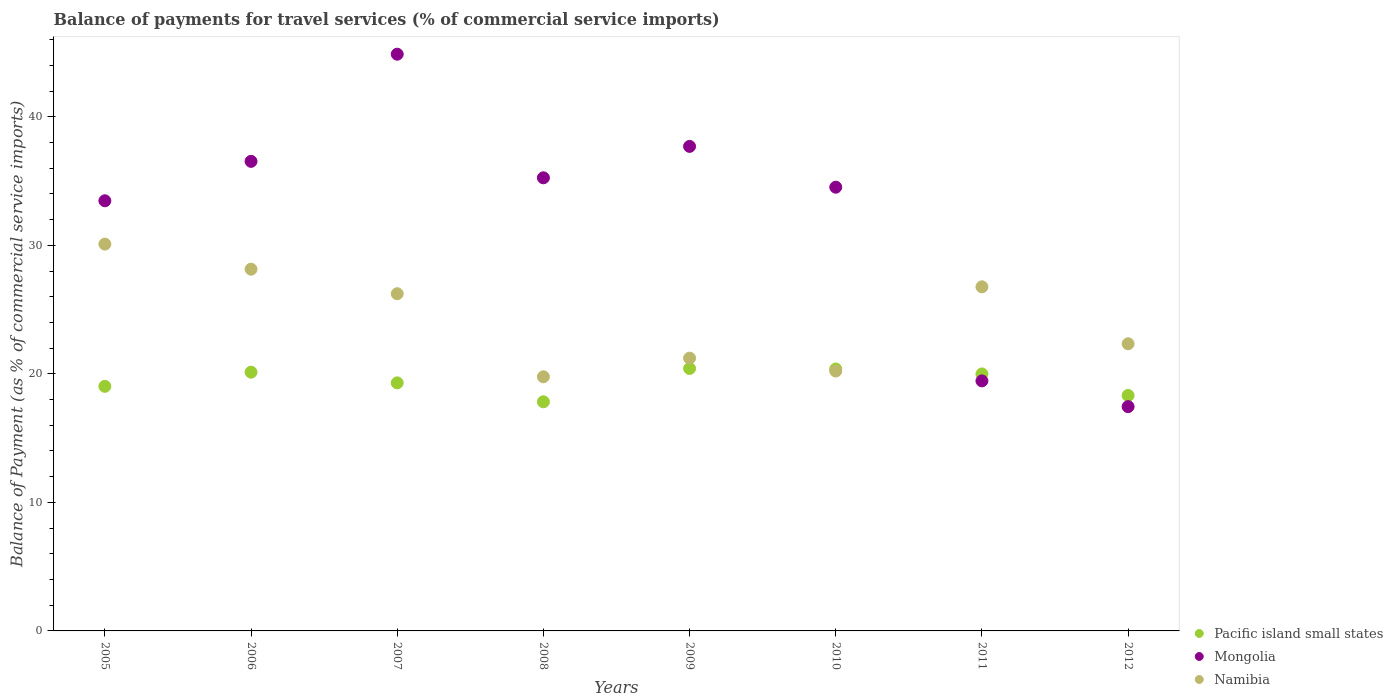How many different coloured dotlines are there?
Your response must be concise. 3. Is the number of dotlines equal to the number of legend labels?
Provide a succinct answer. Yes. What is the balance of payments for travel services in Mongolia in 2008?
Ensure brevity in your answer.  35.26. Across all years, what is the maximum balance of payments for travel services in Mongolia?
Give a very brief answer. 44.87. Across all years, what is the minimum balance of payments for travel services in Pacific island small states?
Your answer should be compact. 17.83. In which year was the balance of payments for travel services in Pacific island small states minimum?
Provide a short and direct response. 2008. What is the total balance of payments for travel services in Mongolia in the graph?
Offer a very short reply. 259.27. What is the difference between the balance of payments for travel services in Pacific island small states in 2008 and that in 2012?
Your response must be concise. -0.49. What is the difference between the balance of payments for travel services in Mongolia in 2006 and the balance of payments for travel services in Namibia in 2007?
Your response must be concise. 10.3. What is the average balance of payments for travel services in Mongolia per year?
Offer a very short reply. 32.41. In the year 2012, what is the difference between the balance of payments for travel services in Namibia and balance of payments for travel services in Pacific island small states?
Offer a terse response. 4.02. What is the ratio of the balance of payments for travel services in Namibia in 2008 to that in 2011?
Offer a very short reply. 0.74. Is the balance of payments for travel services in Namibia in 2005 less than that in 2009?
Make the answer very short. No. Is the difference between the balance of payments for travel services in Namibia in 2007 and 2010 greater than the difference between the balance of payments for travel services in Pacific island small states in 2007 and 2010?
Offer a very short reply. Yes. What is the difference between the highest and the second highest balance of payments for travel services in Namibia?
Ensure brevity in your answer.  1.95. What is the difference between the highest and the lowest balance of payments for travel services in Namibia?
Ensure brevity in your answer.  10.32. In how many years, is the balance of payments for travel services in Pacific island small states greater than the average balance of payments for travel services in Pacific island small states taken over all years?
Ensure brevity in your answer.  4. Is the sum of the balance of payments for travel services in Namibia in 2008 and 2009 greater than the maximum balance of payments for travel services in Pacific island small states across all years?
Make the answer very short. Yes. Is it the case that in every year, the sum of the balance of payments for travel services in Namibia and balance of payments for travel services in Mongolia  is greater than the balance of payments for travel services in Pacific island small states?
Provide a succinct answer. Yes. Does the balance of payments for travel services in Pacific island small states monotonically increase over the years?
Your answer should be compact. No. Is the balance of payments for travel services in Mongolia strictly greater than the balance of payments for travel services in Namibia over the years?
Offer a very short reply. No. How many dotlines are there?
Provide a short and direct response. 3. How many years are there in the graph?
Offer a terse response. 8. Are the values on the major ticks of Y-axis written in scientific E-notation?
Offer a terse response. No. Where does the legend appear in the graph?
Make the answer very short. Bottom right. How many legend labels are there?
Ensure brevity in your answer.  3. What is the title of the graph?
Provide a short and direct response. Balance of payments for travel services (% of commercial service imports). What is the label or title of the Y-axis?
Ensure brevity in your answer.  Balance of Payment (as % of commercial service imports). What is the Balance of Payment (as % of commercial service imports) in Pacific island small states in 2005?
Provide a short and direct response. 19.03. What is the Balance of Payment (as % of commercial service imports) of Mongolia in 2005?
Your answer should be compact. 33.47. What is the Balance of Payment (as % of commercial service imports) in Namibia in 2005?
Your answer should be compact. 30.1. What is the Balance of Payment (as % of commercial service imports) of Pacific island small states in 2006?
Your answer should be very brief. 20.13. What is the Balance of Payment (as % of commercial service imports) of Mongolia in 2006?
Offer a very short reply. 36.54. What is the Balance of Payment (as % of commercial service imports) of Namibia in 2006?
Offer a very short reply. 28.15. What is the Balance of Payment (as % of commercial service imports) in Pacific island small states in 2007?
Keep it short and to the point. 19.3. What is the Balance of Payment (as % of commercial service imports) in Mongolia in 2007?
Keep it short and to the point. 44.87. What is the Balance of Payment (as % of commercial service imports) in Namibia in 2007?
Offer a terse response. 26.24. What is the Balance of Payment (as % of commercial service imports) of Pacific island small states in 2008?
Give a very brief answer. 17.83. What is the Balance of Payment (as % of commercial service imports) in Mongolia in 2008?
Your answer should be very brief. 35.26. What is the Balance of Payment (as % of commercial service imports) of Namibia in 2008?
Your response must be concise. 19.77. What is the Balance of Payment (as % of commercial service imports) of Pacific island small states in 2009?
Keep it short and to the point. 20.42. What is the Balance of Payment (as % of commercial service imports) of Mongolia in 2009?
Provide a short and direct response. 37.7. What is the Balance of Payment (as % of commercial service imports) of Namibia in 2009?
Keep it short and to the point. 21.22. What is the Balance of Payment (as % of commercial service imports) in Pacific island small states in 2010?
Offer a terse response. 20.38. What is the Balance of Payment (as % of commercial service imports) in Mongolia in 2010?
Keep it short and to the point. 34.52. What is the Balance of Payment (as % of commercial service imports) of Namibia in 2010?
Offer a very short reply. 20.22. What is the Balance of Payment (as % of commercial service imports) in Pacific island small states in 2011?
Provide a succinct answer. 20. What is the Balance of Payment (as % of commercial service imports) of Mongolia in 2011?
Provide a succinct answer. 19.45. What is the Balance of Payment (as % of commercial service imports) in Namibia in 2011?
Your response must be concise. 26.77. What is the Balance of Payment (as % of commercial service imports) of Pacific island small states in 2012?
Provide a short and direct response. 18.32. What is the Balance of Payment (as % of commercial service imports) of Mongolia in 2012?
Provide a succinct answer. 17.45. What is the Balance of Payment (as % of commercial service imports) in Namibia in 2012?
Your answer should be compact. 22.34. Across all years, what is the maximum Balance of Payment (as % of commercial service imports) of Pacific island small states?
Offer a terse response. 20.42. Across all years, what is the maximum Balance of Payment (as % of commercial service imports) in Mongolia?
Provide a short and direct response. 44.87. Across all years, what is the maximum Balance of Payment (as % of commercial service imports) in Namibia?
Your response must be concise. 30.1. Across all years, what is the minimum Balance of Payment (as % of commercial service imports) of Pacific island small states?
Your answer should be very brief. 17.83. Across all years, what is the minimum Balance of Payment (as % of commercial service imports) in Mongolia?
Your answer should be compact. 17.45. Across all years, what is the minimum Balance of Payment (as % of commercial service imports) of Namibia?
Keep it short and to the point. 19.77. What is the total Balance of Payment (as % of commercial service imports) in Pacific island small states in the graph?
Make the answer very short. 155.41. What is the total Balance of Payment (as % of commercial service imports) in Mongolia in the graph?
Your answer should be compact. 259.27. What is the total Balance of Payment (as % of commercial service imports) of Namibia in the graph?
Offer a terse response. 194.82. What is the difference between the Balance of Payment (as % of commercial service imports) of Pacific island small states in 2005 and that in 2006?
Your response must be concise. -1.1. What is the difference between the Balance of Payment (as % of commercial service imports) of Mongolia in 2005 and that in 2006?
Ensure brevity in your answer.  -3.07. What is the difference between the Balance of Payment (as % of commercial service imports) in Namibia in 2005 and that in 2006?
Offer a terse response. 1.95. What is the difference between the Balance of Payment (as % of commercial service imports) in Pacific island small states in 2005 and that in 2007?
Your response must be concise. -0.27. What is the difference between the Balance of Payment (as % of commercial service imports) in Mongolia in 2005 and that in 2007?
Offer a very short reply. -11.41. What is the difference between the Balance of Payment (as % of commercial service imports) in Namibia in 2005 and that in 2007?
Your answer should be very brief. 3.86. What is the difference between the Balance of Payment (as % of commercial service imports) of Pacific island small states in 2005 and that in 2008?
Your answer should be very brief. 1.2. What is the difference between the Balance of Payment (as % of commercial service imports) in Mongolia in 2005 and that in 2008?
Give a very brief answer. -1.79. What is the difference between the Balance of Payment (as % of commercial service imports) in Namibia in 2005 and that in 2008?
Your answer should be very brief. 10.32. What is the difference between the Balance of Payment (as % of commercial service imports) of Pacific island small states in 2005 and that in 2009?
Provide a succinct answer. -1.39. What is the difference between the Balance of Payment (as % of commercial service imports) of Mongolia in 2005 and that in 2009?
Offer a terse response. -4.23. What is the difference between the Balance of Payment (as % of commercial service imports) in Namibia in 2005 and that in 2009?
Keep it short and to the point. 8.87. What is the difference between the Balance of Payment (as % of commercial service imports) of Pacific island small states in 2005 and that in 2010?
Your answer should be very brief. -1.35. What is the difference between the Balance of Payment (as % of commercial service imports) in Mongolia in 2005 and that in 2010?
Your response must be concise. -1.06. What is the difference between the Balance of Payment (as % of commercial service imports) in Namibia in 2005 and that in 2010?
Give a very brief answer. 9.88. What is the difference between the Balance of Payment (as % of commercial service imports) of Pacific island small states in 2005 and that in 2011?
Offer a very short reply. -0.97. What is the difference between the Balance of Payment (as % of commercial service imports) in Mongolia in 2005 and that in 2011?
Provide a short and direct response. 14.01. What is the difference between the Balance of Payment (as % of commercial service imports) in Namibia in 2005 and that in 2011?
Provide a short and direct response. 3.32. What is the difference between the Balance of Payment (as % of commercial service imports) of Pacific island small states in 2005 and that in 2012?
Ensure brevity in your answer.  0.71. What is the difference between the Balance of Payment (as % of commercial service imports) in Mongolia in 2005 and that in 2012?
Provide a succinct answer. 16.02. What is the difference between the Balance of Payment (as % of commercial service imports) of Namibia in 2005 and that in 2012?
Offer a terse response. 7.75. What is the difference between the Balance of Payment (as % of commercial service imports) of Pacific island small states in 2006 and that in 2007?
Give a very brief answer. 0.83. What is the difference between the Balance of Payment (as % of commercial service imports) in Mongolia in 2006 and that in 2007?
Offer a terse response. -8.34. What is the difference between the Balance of Payment (as % of commercial service imports) of Namibia in 2006 and that in 2007?
Your response must be concise. 1.91. What is the difference between the Balance of Payment (as % of commercial service imports) of Pacific island small states in 2006 and that in 2008?
Your response must be concise. 2.3. What is the difference between the Balance of Payment (as % of commercial service imports) of Mongolia in 2006 and that in 2008?
Your answer should be very brief. 1.28. What is the difference between the Balance of Payment (as % of commercial service imports) in Namibia in 2006 and that in 2008?
Your response must be concise. 8.37. What is the difference between the Balance of Payment (as % of commercial service imports) in Pacific island small states in 2006 and that in 2009?
Your answer should be compact. -0.29. What is the difference between the Balance of Payment (as % of commercial service imports) of Mongolia in 2006 and that in 2009?
Your response must be concise. -1.16. What is the difference between the Balance of Payment (as % of commercial service imports) of Namibia in 2006 and that in 2009?
Ensure brevity in your answer.  6.92. What is the difference between the Balance of Payment (as % of commercial service imports) of Pacific island small states in 2006 and that in 2010?
Keep it short and to the point. -0.25. What is the difference between the Balance of Payment (as % of commercial service imports) of Mongolia in 2006 and that in 2010?
Provide a succinct answer. 2.01. What is the difference between the Balance of Payment (as % of commercial service imports) of Namibia in 2006 and that in 2010?
Provide a succinct answer. 7.93. What is the difference between the Balance of Payment (as % of commercial service imports) in Pacific island small states in 2006 and that in 2011?
Provide a short and direct response. 0.14. What is the difference between the Balance of Payment (as % of commercial service imports) of Mongolia in 2006 and that in 2011?
Provide a succinct answer. 17.08. What is the difference between the Balance of Payment (as % of commercial service imports) of Namibia in 2006 and that in 2011?
Make the answer very short. 1.37. What is the difference between the Balance of Payment (as % of commercial service imports) of Pacific island small states in 2006 and that in 2012?
Make the answer very short. 1.81. What is the difference between the Balance of Payment (as % of commercial service imports) of Mongolia in 2006 and that in 2012?
Provide a short and direct response. 19.08. What is the difference between the Balance of Payment (as % of commercial service imports) in Namibia in 2006 and that in 2012?
Give a very brief answer. 5.8. What is the difference between the Balance of Payment (as % of commercial service imports) in Pacific island small states in 2007 and that in 2008?
Your answer should be very brief. 1.47. What is the difference between the Balance of Payment (as % of commercial service imports) of Mongolia in 2007 and that in 2008?
Your answer should be very brief. 9.62. What is the difference between the Balance of Payment (as % of commercial service imports) in Namibia in 2007 and that in 2008?
Provide a short and direct response. 6.46. What is the difference between the Balance of Payment (as % of commercial service imports) of Pacific island small states in 2007 and that in 2009?
Ensure brevity in your answer.  -1.12. What is the difference between the Balance of Payment (as % of commercial service imports) of Mongolia in 2007 and that in 2009?
Your response must be concise. 7.17. What is the difference between the Balance of Payment (as % of commercial service imports) in Namibia in 2007 and that in 2009?
Ensure brevity in your answer.  5.01. What is the difference between the Balance of Payment (as % of commercial service imports) of Pacific island small states in 2007 and that in 2010?
Your answer should be compact. -1.08. What is the difference between the Balance of Payment (as % of commercial service imports) of Mongolia in 2007 and that in 2010?
Keep it short and to the point. 10.35. What is the difference between the Balance of Payment (as % of commercial service imports) in Namibia in 2007 and that in 2010?
Provide a short and direct response. 6.01. What is the difference between the Balance of Payment (as % of commercial service imports) in Pacific island small states in 2007 and that in 2011?
Your answer should be compact. -0.7. What is the difference between the Balance of Payment (as % of commercial service imports) of Mongolia in 2007 and that in 2011?
Ensure brevity in your answer.  25.42. What is the difference between the Balance of Payment (as % of commercial service imports) in Namibia in 2007 and that in 2011?
Provide a succinct answer. -0.54. What is the difference between the Balance of Payment (as % of commercial service imports) in Pacific island small states in 2007 and that in 2012?
Give a very brief answer. 0.98. What is the difference between the Balance of Payment (as % of commercial service imports) of Mongolia in 2007 and that in 2012?
Provide a short and direct response. 27.42. What is the difference between the Balance of Payment (as % of commercial service imports) of Namibia in 2007 and that in 2012?
Give a very brief answer. 3.89. What is the difference between the Balance of Payment (as % of commercial service imports) in Pacific island small states in 2008 and that in 2009?
Make the answer very short. -2.59. What is the difference between the Balance of Payment (as % of commercial service imports) of Mongolia in 2008 and that in 2009?
Provide a succinct answer. -2.44. What is the difference between the Balance of Payment (as % of commercial service imports) in Namibia in 2008 and that in 2009?
Offer a terse response. -1.45. What is the difference between the Balance of Payment (as % of commercial service imports) of Pacific island small states in 2008 and that in 2010?
Your response must be concise. -2.55. What is the difference between the Balance of Payment (as % of commercial service imports) in Mongolia in 2008 and that in 2010?
Your answer should be compact. 0.73. What is the difference between the Balance of Payment (as % of commercial service imports) of Namibia in 2008 and that in 2010?
Offer a very short reply. -0.45. What is the difference between the Balance of Payment (as % of commercial service imports) in Pacific island small states in 2008 and that in 2011?
Ensure brevity in your answer.  -2.17. What is the difference between the Balance of Payment (as % of commercial service imports) of Mongolia in 2008 and that in 2011?
Provide a short and direct response. 15.8. What is the difference between the Balance of Payment (as % of commercial service imports) in Namibia in 2008 and that in 2011?
Make the answer very short. -7. What is the difference between the Balance of Payment (as % of commercial service imports) in Pacific island small states in 2008 and that in 2012?
Give a very brief answer. -0.49. What is the difference between the Balance of Payment (as % of commercial service imports) of Mongolia in 2008 and that in 2012?
Ensure brevity in your answer.  17.8. What is the difference between the Balance of Payment (as % of commercial service imports) in Namibia in 2008 and that in 2012?
Give a very brief answer. -2.57. What is the difference between the Balance of Payment (as % of commercial service imports) of Pacific island small states in 2009 and that in 2010?
Your answer should be compact. 0.04. What is the difference between the Balance of Payment (as % of commercial service imports) of Mongolia in 2009 and that in 2010?
Your answer should be compact. 3.18. What is the difference between the Balance of Payment (as % of commercial service imports) of Namibia in 2009 and that in 2010?
Make the answer very short. 1. What is the difference between the Balance of Payment (as % of commercial service imports) in Pacific island small states in 2009 and that in 2011?
Ensure brevity in your answer.  0.42. What is the difference between the Balance of Payment (as % of commercial service imports) of Mongolia in 2009 and that in 2011?
Make the answer very short. 18.25. What is the difference between the Balance of Payment (as % of commercial service imports) of Namibia in 2009 and that in 2011?
Your answer should be very brief. -5.55. What is the difference between the Balance of Payment (as % of commercial service imports) in Pacific island small states in 2009 and that in 2012?
Your answer should be very brief. 2.1. What is the difference between the Balance of Payment (as % of commercial service imports) of Mongolia in 2009 and that in 2012?
Provide a succinct answer. 20.25. What is the difference between the Balance of Payment (as % of commercial service imports) in Namibia in 2009 and that in 2012?
Your response must be concise. -1.12. What is the difference between the Balance of Payment (as % of commercial service imports) in Pacific island small states in 2010 and that in 2011?
Make the answer very short. 0.38. What is the difference between the Balance of Payment (as % of commercial service imports) in Mongolia in 2010 and that in 2011?
Provide a short and direct response. 15.07. What is the difference between the Balance of Payment (as % of commercial service imports) in Namibia in 2010 and that in 2011?
Give a very brief answer. -6.55. What is the difference between the Balance of Payment (as % of commercial service imports) in Pacific island small states in 2010 and that in 2012?
Offer a terse response. 2.06. What is the difference between the Balance of Payment (as % of commercial service imports) in Mongolia in 2010 and that in 2012?
Your response must be concise. 17.07. What is the difference between the Balance of Payment (as % of commercial service imports) of Namibia in 2010 and that in 2012?
Make the answer very short. -2.12. What is the difference between the Balance of Payment (as % of commercial service imports) of Pacific island small states in 2011 and that in 2012?
Provide a succinct answer. 1.68. What is the difference between the Balance of Payment (as % of commercial service imports) in Mongolia in 2011 and that in 2012?
Make the answer very short. 2. What is the difference between the Balance of Payment (as % of commercial service imports) in Namibia in 2011 and that in 2012?
Ensure brevity in your answer.  4.43. What is the difference between the Balance of Payment (as % of commercial service imports) of Pacific island small states in 2005 and the Balance of Payment (as % of commercial service imports) of Mongolia in 2006?
Give a very brief answer. -17.51. What is the difference between the Balance of Payment (as % of commercial service imports) of Pacific island small states in 2005 and the Balance of Payment (as % of commercial service imports) of Namibia in 2006?
Make the answer very short. -9.12. What is the difference between the Balance of Payment (as % of commercial service imports) of Mongolia in 2005 and the Balance of Payment (as % of commercial service imports) of Namibia in 2006?
Make the answer very short. 5.32. What is the difference between the Balance of Payment (as % of commercial service imports) of Pacific island small states in 2005 and the Balance of Payment (as % of commercial service imports) of Mongolia in 2007?
Offer a very short reply. -25.84. What is the difference between the Balance of Payment (as % of commercial service imports) of Pacific island small states in 2005 and the Balance of Payment (as % of commercial service imports) of Namibia in 2007?
Your answer should be very brief. -7.21. What is the difference between the Balance of Payment (as % of commercial service imports) in Mongolia in 2005 and the Balance of Payment (as % of commercial service imports) in Namibia in 2007?
Your answer should be very brief. 7.23. What is the difference between the Balance of Payment (as % of commercial service imports) in Pacific island small states in 2005 and the Balance of Payment (as % of commercial service imports) in Mongolia in 2008?
Provide a succinct answer. -16.23. What is the difference between the Balance of Payment (as % of commercial service imports) of Pacific island small states in 2005 and the Balance of Payment (as % of commercial service imports) of Namibia in 2008?
Ensure brevity in your answer.  -0.74. What is the difference between the Balance of Payment (as % of commercial service imports) of Mongolia in 2005 and the Balance of Payment (as % of commercial service imports) of Namibia in 2008?
Offer a very short reply. 13.69. What is the difference between the Balance of Payment (as % of commercial service imports) in Pacific island small states in 2005 and the Balance of Payment (as % of commercial service imports) in Mongolia in 2009?
Offer a terse response. -18.67. What is the difference between the Balance of Payment (as % of commercial service imports) of Pacific island small states in 2005 and the Balance of Payment (as % of commercial service imports) of Namibia in 2009?
Make the answer very short. -2.19. What is the difference between the Balance of Payment (as % of commercial service imports) of Mongolia in 2005 and the Balance of Payment (as % of commercial service imports) of Namibia in 2009?
Keep it short and to the point. 12.24. What is the difference between the Balance of Payment (as % of commercial service imports) of Pacific island small states in 2005 and the Balance of Payment (as % of commercial service imports) of Mongolia in 2010?
Keep it short and to the point. -15.49. What is the difference between the Balance of Payment (as % of commercial service imports) in Pacific island small states in 2005 and the Balance of Payment (as % of commercial service imports) in Namibia in 2010?
Offer a terse response. -1.19. What is the difference between the Balance of Payment (as % of commercial service imports) of Mongolia in 2005 and the Balance of Payment (as % of commercial service imports) of Namibia in 2010?
Your answer should be compact. 13.25. What is the difference between the Balance of Payment (as % of commercial service imports) of Pacific island small states in 2005 and the Balance of Payment (as % of commercial service imports) of Mongolia in 2011?
Your response must be concise. -0.42. What is the difference between the Balance of Payment (as % of commercial service imports) in Pacific island small states in 2005 and the Balance of Payment (as % of commercial service imports) in Namibia in 2011?
Your response must be concise. -7.74. What is the difference between the Balance of Payment (as % of commercial service imports) of Mongolia in 2005 and the Balance of Payment (as % of commercial service imports) of Namibia in 2011?
Provide a succinct answer. 6.69. What is the difference between the Balance of Payment (as % of commercial service imports) of Pacific island small states in 2005 and the Balance of Payment (as % of commercial service imports) of Mongolia in 2012?
Give a very brief answer. 1.58. What is the difference between the Balance of Payment (as % of commercial service imports) in Pacific island small states in 2005 and the Balance of Payment (as % of commercial service imports) in Namibia in 2012?
Provide a short and direct response. -3.31. What is the difference between the Balance of Payment (as % of commercial service imports) in Mongolia in 2005 and the Balance of Payment (as % of commercial service imports) in Namibia in 2012?
Offer a very short reply. 11.13. What is the difference between the Balance of Payment (as % of commercial service imports) in Pacific island small states in 2006 and the Balance of Payment (as % of commercial service imports) in Mongolia in 2007?
Offer a very short reply. -24.74. What is the difference between the Balance of Payment (as % of commercial service imports) in Pacific island small states in 2006 and the Balance of Payment (as % of commercial service imports) in Namibia in 2007?
Ensure brevity in your answer.  -6.1. What is the difference between the Balance of Payment (as % of commercial service imports) of Mongolia in 2006 and the Balance of Payment (as % of commercial service imports) of Namibia in 2007?
Your answer should be compact. 10.3. What is the difference between the Balance of Payment (as % of commercial service imports) in Pacific island small states in 2006 and the Balance of Payment (as % of commercial service imports) in Mongolia in 2008?
Provide a short and direct response. -15.12. What is the difference between the Balance of Payment (as % of commercial service imports) of Pacific island small states in 2006 and the Balance of Payment (as % of commercial service imports) of Namibia in 2008?
Provide a succinct answer. 0.36. What is the difference between the Balance of Payment (as % of commercial service imports) of Mongolia in 2006 and the Balance of Payment (as % of commercial service imports) of Namibia in 2008?
Keep it short and to the point. 16.76. What is the difference between the Balance of Payment (as % of commercial service imports) in Pacific island small states in 2006 and the Balance of Payment (as % of commercial service imports) in Mongolia in 2009?
Ensure brevity in your answer.  -17.57. What is the difference between the Balance of Payment (as % of commercial service imports) of Pacific island small states in 2006 and the Balance of Payment (as % of commercial service imports) of Namibia in 2009?
Your answer should be compact. -1.09. What is the difference between the Balance of Payment (as % of commercial service imports) in Mongolia in 2006 and the Balance of Payment (as % of commercial service imports) in Namibia in 2009?
Keep it short and to the point. 15.31. What is the difference between the Balance of Payment (as % of commercial service imports) of Pacific island small states in 2006 and the Balance of Payment (as % of commercial service imports) of Mongolia in 2010?
Offer a very short reply. -14.39. What is the difference between the Balance of Payment (as % of commercial service imports) of Pacific island small states in 2006 and the Balance of Payment (as % of commercial service imports) of Namibia in 2010?
Ensure brevity in your answer.  -0.09. What is the difference between the Balance of Payment (as % of commercial service imports) in Mongolia in 2006 and the Balance of Payment (as % of commercial service imports) in Namibia in 2010?
Your response must be concise. 16.32. What is the difference between the Balance of Payment (as % of commercial service imports) of Pacific island small states in 2006 and the Balance of Payment (as % of commercial service imports) of Mongolia in 2011?
Keep it short and to the point. 0.68. What is the difference between the Balance of Payment (as % of commercial service imports) of Pacific island small states in 2006 and the Balance of Payment (as % of commercial service imports) of Namibia in 2011?
Your answer should be very brief. -6.64. What is the difference between the Balance of Payment (as % of commercial service imports) of Mongolia in 2006 and the Balance of Payment (as % of commercial service imports) of Namibia in 2011?
Offer a very short reply. 9.76. What is the difference between the Balance of Payment (as % of commercial service imports) of Pacific island small states in 2006 and the Balance of Payment (as % of commercial service imports) of Mongolia in 2012?
Your response must be concise. 2.68. What is the difference between the Balance of Payment (as % of commercial service imports) of Pacific island small states in 2006 and the Balance of Payment (as % of commercial service imports) of Namibia in 2012?
Your answer should be very brief. -2.21. What is the difference between the Balance of Payment (as % of commercial service imports) of Mongolia in 2006 and the Balance of Payment (as % of commercial service imports) of Namibia in 2012?
Your answer should be very brief. 14.19. What is the difference between the Balance of Payment (as % of commercial service imports) in Pacific island small states in 2007 and the Balance of Payment (as % of commercial service imports) in Mongolia in 2008?
Keep it short and to the point. -15.95. What is the difference between the Balance of Payment (as % of commercial service imports) of Pacific island small states in 2007 and the Balance of Payment (as % of commercial service imports) of Namibia in 2008?
Keep it short and to the point. -0.47. What is the difference between the Balance of Payment (as % of commercial service imports) in Mongolia in 2007 and the Balance of Payment (as % of commercial service imports) in Namibia in 2008?
Provide a short and direct response. 25.1. What is the difference between the Balance of Payment (as % of commercial service imports) in Pacific island small states in 2007 and the Balance of Payment (as % of commercial service imports) in Mongolia in 2009?
Offer a terse response. -18.4. What is the difference between the Balance of Payment (as % of commercial service imports) of Pacific island small states in 2007 and the Balance of Payment (as % of commercial service imports) of Namibia in 2009?
Ensure brevity in your answer.  -1.92. What is the difference between the Balance of Payment (as % of commercial service imports) of Mongolia in 2007 and the Balance of Payment (as % of commercial service imports) of Namibia in 2009?
Provide a short and direct response. 23.65. What is the difference between the Balance of Payment (as % of commercial service imports) of Pacific island small states in 2007 and the Balance of Payment (as % of commercial service imports) of Mongolia in 2010?
Your answer should be compact. -15.22. What is the difference between the Balance of Payment (as % of commercial service imports) of Pacific island small states in 2007 and the Balance of Payment (as % of commercial service imports) of Namibia in 2010?
Provide a short and direct response. -0.92. What is the difference between the Balance of Payment (as % of commercial service imports) of Mongolia in 2007 and the Balance of Payment (as % of commercial service imports) of Namibia in 2010?
Keep it short and to the point. 24.65. What is the difference between the Balance of Payment (as % of commercial service imports) of Pacific island small states in 2007 and the Balance of Payment (as % of commercial service imports) of Mongolia in 2011?
Keep it short and to the point. -0.15. What is the difference between the Balance of Payment (as % of commercial service imports) in Pacific island small states in 2007 and the Balance of Payment (as % of commercial service imports) in Namibia in 2011?
Provide a succinct answer. -7.47. What is the difference between the Balance of Payment (as % of commercial service imports) of Mongolia in 2007 and the Balance of Payment (as % of commercial service imports) of Namibia in 2011?
Make the answer very short. 18.1. What is the difference between the Balance of Payment (as % of commercial service imports) of Pacific island small states in 2007 and the Balance of Payment (as % of commercial service imports) of Mongolia in 2012?
Your response must be concise. 1.85. What is the difference between the Balance of Payment (as % of commercial service imports) of Pacific island small states in 2007 and the Balance of Payment (as % of commercial service imports) of Namibia in 2012?
Offer a terse response. -3.04. What is the difference between the Balance of Payment (as % of commercial service imports) in Mongolia in 2007 and the Balance of Payment (as % of commercial service imports) in Namibia in 2012?
Provide a short and direct response. 22.53. What is the difference between the Balance of Payment (as % of commercial service imports) of Pacific island small states in 2008 and the Balance of Payment (as % of commercial service imports) of Mongolia in 2009?
Your answer should be compact. -19.87. What is the difference between the Balance of Payment (as % of commercial service imports) in Pacific island small states in 2008 and the Balance of Payment (as % of commercial service imports) in Namibia in 2009?
Offer a terse response. -3.4. What is the difference between the Balance of Payment (as % of commercial service imports) in Mongolia in 2008 and the Balance of Payment (as % of commercial service imports) in Namibia in 2009?
Give a very brief answer. 14.03. What is the difference between the Balance of Payment (as % of commercial service imports) in Pacific island small states in 2008 and the Balance of Payment (as % of commercial service imports) in Mongolia in 2010?
Provide a succinct answer. -16.7. What is the difference between the Balance of Payment (as % of commercial service imports) in Pacific island small states in 2008 and the Balance of Payment (as % of commercial service imports) in Namibia in 2010?
Your answer should be compact. -2.39. What is the difference between the Balance of Payment (as % of commercial service imports) in Mongolia in 2008 and the Balance of Payment (as % of commercial service imports) in Namibia in 2010?
Provide a succinct answer. 15.03. What is the difference between the Balance of Payment (as % of commercial service imports) in Pacific island small states in 2008 and the Balance of Payment (as % of commercial service imports) in Mongolia in 2011?
Offer a very short reply. -1.63. What is the difference between the Balance of Payment (as % of commercial service imports) in Pacific island small states in 2008 and the Balance of Payment (as % of commercial service imports) in Namibia in 2011?
Ensure brevity in your answer.  -8.95. What is the difference between the Balance of Payment (as % of commercial service imports) in Mongolia in 2008 and the Balance of Payment (as % of commercial service imports) in Namibia in 2011?
Make the answer very short. 8.48. What is the difference between the Balance of Payment (as % of commercial service imports) of Pacific island small states in 2008 and the Balance of Payment (as % of commercial service imports) of Mongolia in 2012?
Your answer should be compact. 0.38. What is the difference between the Balance of Payment (as % of commercial service imports) in Pacific island small states in 2008 and the Balance of Payment (as % of commercial service imports) in Namibia in 2012?
Give a very brief answer. -4.51. What is the difference between the Balance of Payment (as % of commercial service imports) of Mongolia in 2008 and the Balance of Payment (as % of commercial service imports) of Namibia in 2012?
Your answer should be very brief. 12.91. What is the difference between the Balance of Payment (as % of commercial service imports) in Pacific island small states in 2009 and the Balance of Payment (as % of commercial service imports) in Mongolia in 2010?
Give a very brief answer. -14.11. What is the difference between the Balance of Payment (as % of commercial service imports) in Pacific island small states in 2009 and the Balance of Payment (as % of commercial service imports) in Namibia in 2010?
Offer a terse response. 0.2. What is the difference between the Balance of Payment (as % of commercial service imports) in Mongolia in 2009 and the Balance of Payment (as % of commercial service imports) in Namibia in 2010?
Ensure brevity in your answer.  17.48. What is the difference between the Balance of Payment (as % of commercial service imports) of Pacific island small states in 2009 and the Balance of Payment (as % of commercial service imports) of Mongolia in 2011?
Your response must be concise. 0.96. What is the difference between the Balance of Payment (as % of commercial service imports) of Pacific island small states in 2009 and the Balance of Payment (as % of commercial service imports) of Namibia in 2011?
Give a very brief answer. -6.36. What is the difference between the Balance of Payment (as % of commercial service imports) of Mongolia in 2009 and the Balance of Payment (as % of commercial service imports) of Namibia in 2011?
Offer a terse response. 10.93. What is the difference between the Balance of Payment (as % of commercial service imports) of Pacific island small states in 2009 and the Balance of Payment (as % of commercial service imports) of Mongolia in 2012?
Make the answer very short. 2.97. What is the difference between the Balance of Payment (as % of commercial service imports) in Pacific island small states in 2009 and the Balance of Payment (as % of commercial service imports) in Namibia in 2012?
Your answer should be compact. -1.92. What is the difference between the Balance of Payment (as % of commercial service imports) of Mongolia in 2009 and the Balance of Payment (as % of commercial service imports) of Namibia in 2012?
Offer a very short reply. 15.36. What is the difference between the Balance of Payment (as % of commercial service imports) in Pacific island small states in 2010 and the Balance of Payment (as % of commercial service imports) in Mongolia in 2011?
Make the answer very short. 0.93. What is the difference between the Balance of Payment (as % of commercial service imports) of Pacific island small states in 2010 and the Balance of Payment (as % of commercial service imports) of Namibia in 2011?
Offer a terse response. -6.39. What is the difference between the Balance of Payment (as % of commercial service imports) in Mongolia in 2010 and the Balance of Payment (as % of commercial service imports) in Namibia in 2011?
Offer a very short reply. 7.75. What is the difference between the Balance of Payment (as % of commercial service imports) of Pacific island small states in 2010 and the Balance of Payment (as % of commercial service imports) of Mongolia in 2012?
Provide a succinct answer. 2.93. What is the difference between the Balance of Payment (as % of commercial service imports) in Pacific island small states in 2010 and the Balance of Payment (as % of commercial service imports) in Namibia in 2012?
Give a very brief answer. -1.96. What is the difference between the Balance of Payment (as % of commercial service imports) of Mongolia in 2010 and the Balance of Payment (as % of commercial service imports) of Namibia in 2012?
Offer a terse response. 12.18. What is the difference between the Balance of Payment (as % of commercial service imports) in Pacific island small states in 2011 and the Balance of Payment (as % of commercial service imports) in Mongolia in 2012?
Your response must be concise. 2.55. What is the difference between the Balance of Payment (as % of commercial service imports) of Pacific island small states in 2011 and the Balance of Payment (as % of commercial service imports) of Namibia in 2012?
Provide a short and direct response. -2.35. What is the difference between the Balance of Payment (as % of commercial service imports) of Mongolia in 2011 and the Balance of Payment (as % of commercial service imports) of Namibia in 2012?
Offer a terse response. -2.89. What is the average Balance of Payment (as % of commercial service imports) of Pacific island small states per year?
Ensure brevity in your answer.  19.43. What is the average Balance of Payment (as % of commercial service imports) in Mongolia per year?
Your answer should be compact. 32.41. What is the average Balance of Payment (as % of commercial service imports) of Namibia per year?
Your answer should be compact. 24.35. In the year 2005, what is the difference between the Balance of Payment (as % of commercial service imports) of Pacific island small states and Balance of Payment (as % of commercial service imports) of Mongolia?
Keep it short and to the point. -14.44. In the year 2005, what is the difference between the Balance of Payment (as % of commercial service imports) of Pacific island small states and Balance of Payment (as % of commercial service imports) of Namibia?
Provide a short and direct response. -11.07. In the year 2005, what is the difference between the Balance of Payment (as % of commercial service imports) in Mongolia and Balance of Payment (as % of commercial service imports) in Namibia?
Your answer should be very brief. 3.37. In the year 2006, what is the difference between the Balance of Payment (as % of commercial service imports) in Pacific island small states and Balance of Payment (as % of commercial service imports) in Mongolia?
Give a very brief answer. -16.4. In the year 2006, what is the difference between the Balance of Payment (as % of commercial service imports) of Pacific island small states and Balance of Payment (as % of commercial service imports) of Namibia?
Your answer should be very brief. -8.01. In the year 2006, what is the difference between the Balance of Payment (as % of commercial service imports) of Mongolia and Balance of Payment (as % of commercial service imports) of Namibia?
Ensure brevity in your answer.  8.39. In the year 2007, what is the difference between the Balance of Payment (as % of commercial service imports) of Pacific island small states and Balance of Payment (as % of commercial service imports) of Mongolia?
Provide a succinct answer. -25.57. In the year 2007, what is the difference between the Balance of Payment (as % of commercial service imports) of Pacific island small states and Balance of Payment (as % of commercial service imports) of Namibia?
Your response must be concise. -6.93. In the year 2007, what is the difference between the Balance of Payment (as % of commercial service imports) of Mongolia and Balance of Payment (as % of commercial service imports) of Namibia?
Offer a very short reply. 18.64. In the year 2008, what is the difference between the Balance of Payment (as % of commercial service imports) in Pacific island small states and Balance of Payment (as % of commercial service imports) in Mongolia?
Provide a succinct answer. -17.43. In the year 2008, what is the difference between the Balance of Payment (as % of commercial service imports) of Pacific island small states and Balance of Payment (as % of commercial service imports) of Namibia?
Provide a succinct answer. -1.95. In the year 2008, what is the difference between the Balance of Payment (as % of commercial service imports) of Mongolia and Balance of Payment (as % of commercial service imports) of Namibia?
Make the answer very short. 15.48. In the year 2009, what is the difference between the Balance of Payment (as % of commercial service imports) in Pacific island small states and Balance of Payment (as % of commercial service imports) in Mongolia?
Ensure brevity in your answer.  -17.28. In the year 2009, what is the difference between the Balance of Payment (as % of commercial service imports) in Pacific island small states and Balance of Payment (as % of commercial service imports) in Namibia?
Offer a terse response. -0.81. In the year 2009, what is the difference between the Balance of Payment (as % of commercial service imports) of Mongolia and Balance of Payment (as % of commercial service imports) of Namibia?
Provide a succinct answer. 16.48. In the year 2010, what is the difference between the Balance of Payment (as % of commercial service imports) in Pacific island small states and Balance of Payment (as % of commercial service imports) in Mongolia?
Offer a very short reply. -14.14. In the year 2010, what is the difference between the Balance of Payment (as % of commercial service imports) in Pacific island small states and Balance of Payment (as % of commercial service imports) in Namibia?
Offer a terse response. 0.16. In the year 2010, what is the difference between the Balance of Payment (as % of commercial service imports) of Mongolia and Balance of Payment (as % of commercial service imports) of Namibia?
Your answer should be compact. 14.3. In the year 2011, what is the difference between the Balance of Payment (as % of commercial service imports) in Pacific island small states and Balance of Payment (as % of commercial service imports) in Mongolia?
Make the answer very short. 0.54. In the year 2011, what is the difference between the Balance of Payment (as % of commercial service imports) in Pacific island small states and Balance of Payment (as % of commercial service imports) in Namibia?
Your answer should be compact. -6.78. In the year 2011, what is the difference between the Balance of Payment (as % of commercial service imports) in Mongolia and Balance of Payment (as % of commercial service imports) in Namibia?
Offer a very short reply. -7.32. In the year 2012, what is the difference between the Balance of Payment (as % of commercial service imports) in Pacific island small states and Balance of Payment (as % of commercial service imports) in Mongolia?
Your response must be concise. 0.87. In the year 2012, what is the difference between the Balance of Payment (as % of commercial service imports) in Pacific island small states and Balance of Payment (as % of commercial service imports) in Namibia?
Your response must be concise. -4.02. In the year 2012, what is the difference between the Balance of Payment (as % of commercial service imports) in Mongolia and Balance of Payment (as % of commercial service imports) in Namibia?
Your answer should be compact. -4.89. What is the ratio of the Balance of Payment (as % of commercial service imports) of Pacific island small states in 2005 to that in 2006?
Provide a succinct answer. 0.95. What is the ratio of the Balance of Payment (as % of commercial service imports) in Mongolia in 2005 to that in 2006?
Ensure brevity in your answer.  0.92. What is the ratio of the Balance of Payment (as % of commercial service imports) in Namibia in 2005 to that in 2006?
Offer a terse response. 1.07. What is the ratio of the Balance of Payment (as % of commercial service imports) in Mongolia in 2005 to that in 2007?
Your answer should be very brief. 0.75. What is the ratio of the Balance of Payment (as % of commercial service imports) in Namibia in 2005 to that in 2007?
Provide a short and direct response. 1.15. What is the ratio of the Balance of Payment (as % of commercial service imports) in Pacific island small states in 2005 to that in 2008?
Your response must be concise. 1.07. What is the ratio of the Balance of Payment (as % of commercial service imports) of Mongolia in 2005 to that in 2008?
Your answer should be very brief. 0.95. What is the ratio of the Balance of Payment (as % of commercial service imports) of Namibia in 2005 to that in 2008?
Your answer should be compact. 1.52. What is the ratio of the Balance of Payment (as % of commercial service imports) in Pacific island small states in 2005 to that in 2009?
Provide a succinct answer. 0.93. What is the ratio of the Balance of Payment (as % of commercial service imports) in Mongolia in 2005 to that in 2009?
Keep it short and to the point. 0.89. What is the ratio of the Balance of Payment (as % of commercial service imports) of Namibia in 2005 to that in 2009?
Your response must be concise. 1.42. What is the ratio of the Balance of Payment (as % of commercial service imports) of Pacific island small states in 2005 to that in 2010?
Ensure brevity in your answer.  0.93. What is the ratio of the Balance of Payment (as % of commercial service imports) in Mongolia in 2005 to that in 2010?
Your answer should be very brief. 0.97. What is the ratio of the Balance of Payment (as % of commercial service imports) of Namibia in 2005 to that in 2010?
Give a very brief answer. 1.49. What is the ratio of the Balance of Payment (as % of commercial service imports) of Pacific island small states in 2005 to that in 2011?
Provide a succinct answer. 0.95. What is the ratio of the Balance of Payment (as % of commercial service imports) of Mongolia in 2005 to that in 2011?
Keep it short and to the point. 1.72. What is the ratio of the Balance of Payment (as % of commercial service imports) of Namibia in 2005 to that in 2011?
Make the answer very short. 1.12. What is the ratio of the Balance of Payment (as % of commercial service imports) of Pacific island small states in 2005 to that in 2012?
Make the answer very short. 1.04. What is the ratio of the Balance of Payment (as % of commercial service imports) in Mongolia in 2005 to that in 2012?
Offer a very short reply. 1.92. What is the ratio of the Balance of Payment (as % of commercial service imports) in Namibia in 2005 to that in 2012?
Provide a short and direct response. 1.35. What is the ratio of the Balance of Payment (as % of commercial service imports) in Pacific island small states in 2006 to that in 2007?
Ensure brevity in your answer.  1.04. What is the ratio of the Balance of Payment (as % of commercial service imports) of Mongolia in 2006 to that in 2007?
Your answer should be compact. 0.81. What is the ratio of the Balance of Payment (as % of commercial service imports) of Namibia in 2006 to that in 2007?
Provide a short and direct response. 1.07. What is the ratio of the Balance of Payment (as % of commercial service imports) in Pacific island small states in 2006 to that in 2008?
Keep it short and to the point. 1.13. What is the ratio of the Balance of Payment (as % of commercial service imports) of Mongolia in 2006 to that in 2008?
Provide a succinct answer. 1.04. What is the ratio of the Balance of Payment (as % of commercial service imports) in Namibia in 2006 to that in 2008?
Provide a succinct answer. 1.42. What is the ratio of the Balance of Payment (as % of commercial service imports) in Mongolia in 2006 to that in 2009?
Your answer should be compact. 0.97. What is the ratio of the Balance of Payment (as % of commercial service imports) of Namibia in 2006 to that in 2009?
Provide a succinct answer. 1.33. What is the ratio of the Balance of Payment (as % of commercial service imports) in Pacific island small states in 2006 to that in 2010?
Offer a terse response. 0.99. What is the ratio of the Balance of Payment (as % of commercial service imports) of Mongolia in 2006 to that in 2010?
Provide a short and direct response. 1.06. What is the ratio of the Balance of Payment (as % of commercial service imports) of Namibia in 2006 to that in 2010?
Your response must be concise. 1.39. What is the ratio of the Balance of Payment (as % of commercial service imports) of Pacific island small states in 2006 to that in 2011?
Your response must be concise. 1.01. What is the ratio of the Balance of Payment (as % of commercial service imports) of Mongolia in 2006 to that in 2011?
Your answer should be compact. 1.88. What is the ratio of the Balance of Payment (as % of commercial service imports) of Namibia in 2006 to that in 2011?
Keep it short and to the point. 1.05. What is the ratio of the Balance of Payment (as % of commercial service imports) in Pacific island small states in 2006 to that in 2012?
Offer a terse response. 1.1. What is the ratio of the Balance of Payment (as % of commercial service imports) of Mongolia in 2006 to that in 2012?
Give a very brief answer. 2.09. What is the ratio of the Balance of Payment (as % of commercial service imports) in Namibia in 2006 to that in 2012?
Provide a succinct answer. 1.26. What is the ratio of the Balance of Payment (as % of commercial service imports) of Pacific island small states in 2007 to that in 2008?
Offer a very short reply. 1.08. What is the ratio of the Balance of Payment (as % of commercial service imports) of Mongolia in 2007 to that in 2008?
Provide a short and direct response. 1.27. What is the ratio of the Balance of Payment (as % of commercial service imports) of Namibia in 2007 to that in 2008?
Make the answer very short. 1.33. What is the ratio of the Balance of Payment (as % of commercial service imports) in Pacific island small states in 2007 to that in 2009?
Ensure brevity in your answer.  0.95. What is the ratio of the Balance of Payment (as % of commercial service imports) of Mongolia in 2007 to that in 2009?
Make the answer very short. 1.19. What is the ratio of the Balance of Payment (as % of commercial service imports) in Namibia in 2007 to that in 2009?
Give a very brief answer. 1.24. What is the ratio of the Balance of Payment (as % of commercial service imports) in Pacific island small states in 2007 to that in 2010?
Make the answer very short. 0.95. What is the ratio of the Balance of Payment (as % of commercial service imports) in Mongolia in 2007 to that in 2010?
Make the answer very short. 1.3. What is the ratio of the Balance of Payment (as % of commercial service imports) of Namibia in 2007 to that in 2010?
Offer a terse response. 1.3. What is the ratio of the Balance of Payment (as % of commercial service imports) of Pacific island small states in 2007 to that in 2011?
Ensure brevity in your answer.  0.97. What is the ratio of the Balance of Payment (as % of commercial service imports) in Mongolia in 2007 to that in 2011?
Make the answer very short. 2.31. What is the ratio of the Balance of Payment (as % of commercial service imports) in Namibia in 2007 to that in 2011?
Offer a very short reply. 0.98. What is the ratio of the Balance of Payment (as % of commercial service imports) of Pacific island small states in 2007 to that in 2012?
Your response must be concise. 1.05. What is the ratio of the Balance of Payment (as % of commercial service imports) of Mongolia in 2007 to that in 2012?
Offer a terse response. 2.57. What is the ratio of the Balance of Payment (as % of commercial service imports) of Namibia in 2007 to that in 2012?
Give a very brief answer. 1.17. What is the ratio of the Balance of Payment (as % of commercial service imports) in Pacific island small states in 2008 to that in 2009?
Offer a terse response. 0.87. What is the ratio of the Balance of Payment (as % of commercial service imports) in Mongolia in 2008 to that in 2009?
Make the answer very short. 0.94. What is the ratio of the Balance of Payment (as % of commercial service imports) of Namibia in 2008 to that in 2009?
Ensure brevity in your answer.  0.93. What is the ratio of the Balance of Payment (as % of commercial service imports) in Pacific island small states in 2008 to that in 2010?
Your answer should be very brief. 0.87. What is the ratio of the Balance of Payment (as % of commercial service imports) of Mongolia in 2008 to that in 2010?
Ensure brevity in your answer.  1.02. What is the ratio of the Balance of Payment (as % of commercial service imports) in Namibia in 2008 to that in 2010?
Ensure brevity in your answer.  0.98. What is the ratio of the Balance of Payment (as % of commercial service imports) of Pacific island small states in 2008 to that in 2011?
Keep it short and to the point. 0.89. What is the ratio of the Balance of Payment (as % of commercial service imports) of Mongolia in 2008 to that in 2011?
Your answer should be very brief. 1.81. What is the ratio of the Balance of Payment (as % of commercial service imports) in Namibia in 2008 to that in 2011?
Your answer should be very brief. 0.74. What is the ratio of the Balance of Payment (as % of commercial service imports) in Pacific island small states in 2008 to that in 2012?
Offer a terse response. 0.97. What is the ratio of the Balance of Payment (as % of commercial service imports) of Mongolia in 2008 to that in 2012?
Offer a terse response. 2.02. What is the ratio of the Balance of Payment (as % of commercial service imports) of Namibia in 2008 to that in 2012?
Offer a terse response. 0.89. What is the ratio of the Balance of Payment (as % of commercial service imports) of Pacific island small states in 2009 to that in 2010?
Offer a very short reply. 1. What is the ratio of the Balance of Payment (as % of commercial service imports) of Mongolia in 2009 to that in 2010?
Your answer should be compact. 1.09. What is the ratio of the Balance of Payment (as % of commercial service imports) of Namibia in 2009 to that in 2010?
Offer a terse response. 1.05. What is the ratio of the Balance of Payment (as % of commercial service imports) in Pacific island small states in 2009 to that in 2011?
Make the answer very short. 1.02. What is the ratio of the Balance of Payment (as % of commercial service imports) in Mongolia in 2009 to that in 2011?
Make the answer very short. 1.94. What is the ratio of the Balance of Payment (as % of commercial service imports) in Namibia in 2009 to that in 2011?
Make the answer very short. 0.79. What is the ratio of the Balance of Payment (as % of commercial service imports) of Pacific island small states in 2009 to that in 2012?
Ensure brevity in your answer.  1.11. What is the ratio of the Balance of Payment (as % of commercial service imports) of Mongolia in 2009 to that in 2012?
Offer a very short reply. 2.16. What is the ratio of the Balance of Payment (as % of commercial service imports) of Namibia in 2009 to that in 2012?
Make the answer very short. 0.95. What is the ratio of the Balance of Payment (as % of commercial service imports) of Pacific island small states in 2010 to that in 2011?
Provide a succinct answer. 1.02. What is the ratio of the Balance of Payment (as % of commercial service imports) of Mongolia in 2010 to that in 2011?
Your answer should be very brief. 1.77. What is the ratio of the Balance of Payment (as % of commercial service imports) in Namibia in 2010 to that in 2011?
Provide a succinct answer. 0.76. What is the ratio of the Balance of Payment (as % of commercial service imports) in Pacific island small states in 2010 to that in 2012?
Keep it short and to the point. 1.11. What is the ratio of the Balance of Payment (as % of commercial service imports) of Mongolia in 2010 to that in 2012?
Your answer should be compact. 1.98. What is the ratio of the Balance of Payment (as % of commercial service imports) of Namibia in 2010 to that in 2012?
Ensure brevity in your answer.  0.91. What is the ratio of the Balance of Payment (as % of commercial service imports) in Pacific island small states in 2011 to that in 2012?
Offer a very short reply. 1.09. What is the ratio of the Balance of Payment (as % of commercial service imports) in Mongolia in 2011 to that in 2012?
Offer a terse response. 1.11. What is the ratio of the Balance of Payment (as % of commercial service imports) in Namibia in 2011 to that in 2012?
Give a very brief answer. 1.2. What is the difference between the highest and the second highest Balance of Payment (as % of commercial service imports) of Pacific island small states?
Offer a terse response. 0.04. What is the difference between the highest and the second highest Balance of Payment (as % of commercial service imports) in Mongolia?
Ensure brevity in your answer.  7.17. What is the difference between the highest and the second highest Balance of Payment (as % of commercial service imports) of Namibia?
Provide a succinct answer. 1.95. What is the difference between the highest and the lowest Balance of Payment (as % of commercial service imports) in Pacific island small states?
Offer a terse response. 2.59. What is the difference between the highest and the lowest Balance of Payment (as % of commercial service imports) of Mongolia?
Give a very brief answer. 27.42. What is the difference between the highest and the lowest Balance of Payment (as % of commercial service imports) in Namibia?
Offer a very short reply. 10.32. 